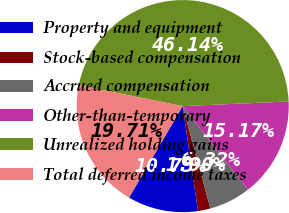Convert chart. <chart><loc_0><loc_0><loc_500><loc_500><pie_chart><fcel>Property and equipment<fcel>Stock-based compensation<fcel>Accrued compensation<fcel>Other-than-temporary<fcel>Unrealized holding gains<fcel>Total deferred income taxes<nl><fcel>10.75%<fcel>1.9%<fcel>6.32%<fcel>15.17%<fcel>46.14%<fcel>19.71%<nl></chart> 